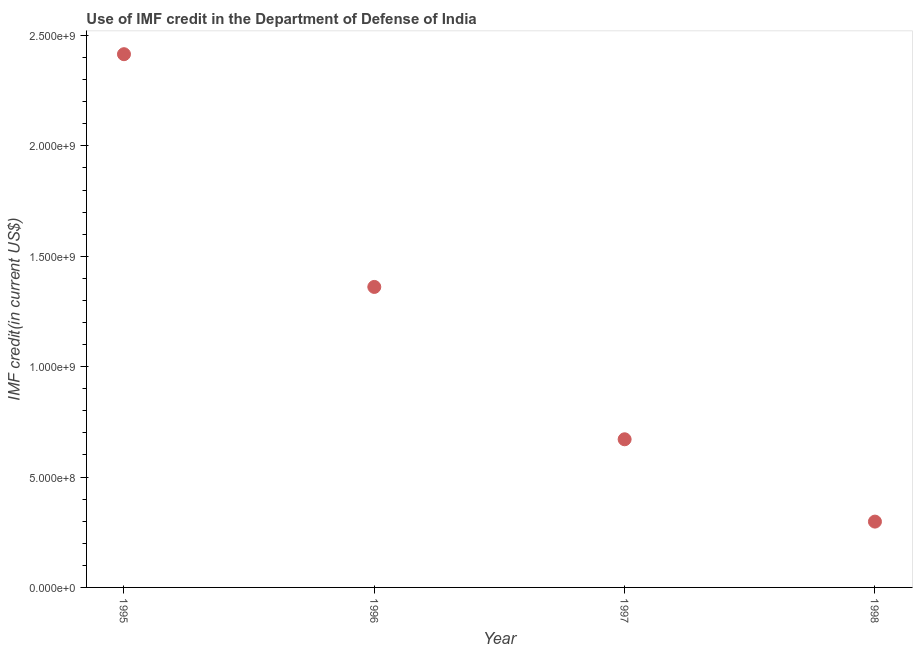What is the use of imf credit in dod in 1995?
Offer a terse response. 2.42e+09. Across all years, what is the maximum use of imf credit in dod?
Provide a succinct answer. 2.42e+09. Across all years, what is the minimum use of imf credit in dod?
Make the answer very short. 2.98e+08. In which year was the use of imf credit in dod minimum?
Your answer should be very brief. 1998. What is the sum of the use of imf credit in dod?
Offer a very short reply. 4.75e+09. What is the difference between the use of imf credit in dod in 1995 and 1997?
Provide a succinct answer. 1.74e+09. What is the average use of imf credit in dod per year?
Your answer should be very brief. 1.19e+09. What is the median use of imf credit in dod?
Ensure brevity in your answer.  1.02e+09. Do a majority of the years between 1997 and 1996 (inclusive) have use of imf credit in dod greater than 700000000 US$?
Give a very brief answer. No. What is the ratio of the use of imf credit in dod in 1996 to that in 1998?
Provide a succinct answer. 4.57. Is the difference between the use of imf credit in dod in 1995 and 1998 greater than the difference between any two years?
Your response must be concise. Yes. What is the difference between the highest and the second highest use of imf credit in dod?
Make the answer very short. 1.05e+09. What is the difference between the highest and the lowest use of imf credit in dod?
Offer a terse response. 2.12e+09. In how many years, is the use of imf credit in dod greater than the average use of imf credit in dod taken over all years?
Your answer should be very brief. 2. How many dotlines are there?
Your response must be concise. 1. How many years are there in the graph?
Your answer should be very brief. 4. Does the graph contain any zero values?
Offer a very short reply. No. What is the title of the graph?
Offer a very short reply. Use of IMF credit in the Department of Defense of India. What is the label or title of the X-axis?
Keep it short and to the point. Year. What is the label or title of the Y-axis?
Provide a succinct answer. IMF credit(in current US$). What is the IMF credit(in current US$) in 1995?
Make the answer very short. 2.42e+09. What is the IMF credit(in current US$) in 1996?
Your answer should be very brief. 1.36e+09. What is the IMF credit(in current US$) in 1997?
Your response must be concise. 6.71e+08. What is the IMF credit(in current US$) in 1998?
Provide a short and direct response. 2.98e+08. What is the difference between the IMF credit(in current US$) in 1995 and 1996?
Keep it short and to the point. 1.05e+09. What is the difference between the IMF credit(in current US$) in 1995 and 1997?
Your response must be concise. 1.74e+09. What is the difference between the IMF credit(in current US$) in 1995 and 1998?
Keep it short and to the point. 2.12e+09. What is the difference between the IMF credit(in current US$) in 1996 and 1997?
Offer a very short reply. 6.90e+08. What is the difference between the IMF credit(in current US$) in 1996 and 1998?
Your answer should be very brief. 1.06e+09. What is the difference between the IMF credit(in current US$) in 1997 and 1998?
Your response must be concise. 3.73e+08. What is the ratio of the IMF credit(in current US$) in 1995 to that in 1996?
Provide a succinct answer. 1.77. What is the ratio of the IMF credit(in current US$) in 1995 to that in 1997?
Keep it short and to the point. 3.6. What is the ratio of the IMF credit(in current US$) in 1995 to that in 1998?
Keep it short and to the point. 8.1. What is the ratio of the IMF credit(in current US$) in 1996 to that in 1997?
Your answer should be very brief. 2.03. What is the ratio of the IMF credit(in current US$) in 1996 to that in 1998?
Provide a short and direct response. 4.57. What is the ratio of the IMF credit(in current US$) in 1997 to that in 1998?
Provide a succinct answer. 2.25. 